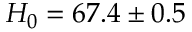<formula> <loc_0><loc_0><loc_500><loc_500>H _ { 0 } = 6 7 . 4 \pm 0 . 5</formula> 